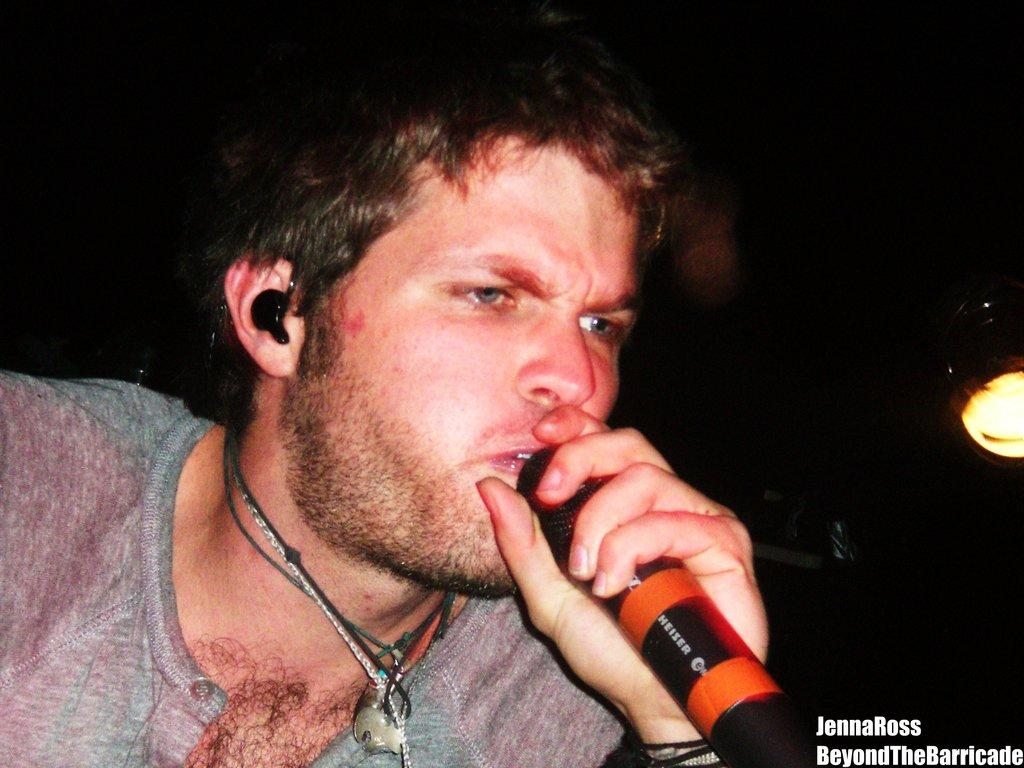What is the person holding in their left hand in the image? The person is holding a microphone in their left hand. What type of audio equipment is the person wearing? The person is wearing earphones. What type of accessory is visible around the person's neck? There is a chain and a black thread around the person's neck. What type of oatmeal is being served at the airport in the image? There is no oatmeal or airport present in the image; it features a person holding a microphone and wearing earphones and neck accessories. 